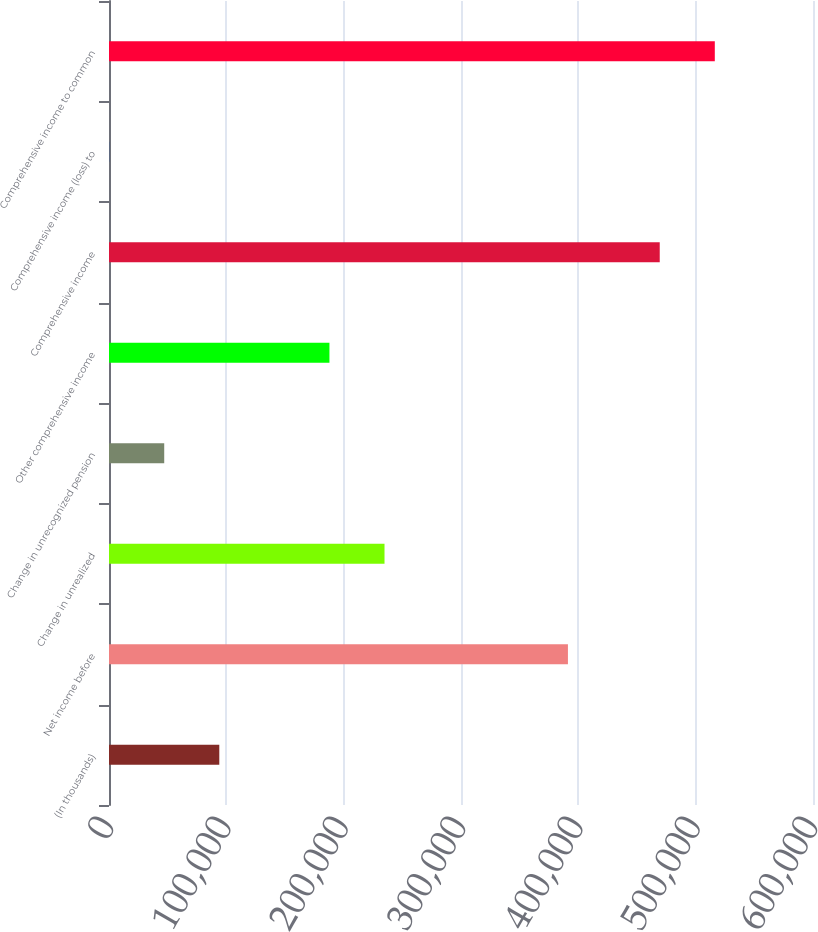<chart> <loc_0><loc_0><loc_500><loc_500><bar_chart><fcel>(In thousands)<fcel>Net income before<fcel>Change in unrealized<fcel>Change in unrecognized pension<fcel>Other comprehensive income<fcel>Comprehensive income<fcel>Comprehensive income (loss) to<fcel>Comprehensive income to common<nl><fcel>93999.8<fcel>391141<fcel>234812<fcel>47062.4<fcel>187875<fcel>469374<fcel>125<fcel>516311<nl></chart> 